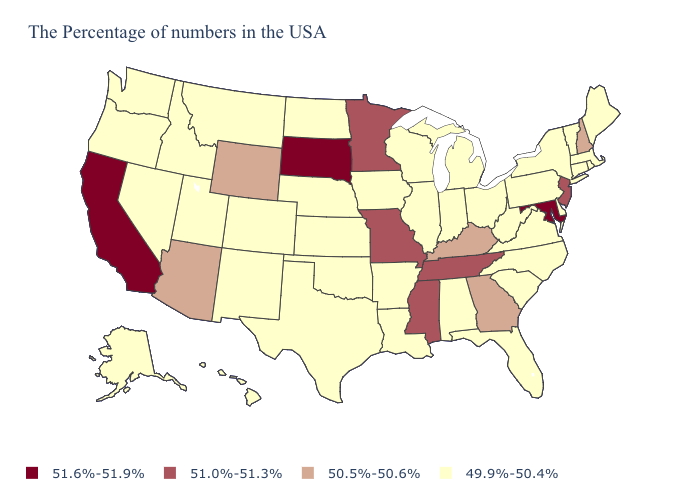Among the states that border Mississippi , does Tennessee have the lowest value?
Short answer required. No. Does Wyoming have the lowest value in the West?
Give a very brief answer. No. What is the value of West Virginia?
Concise answer only. 49.9%-50.4%. Does New Hampshire have the highest value in the USA?
Concise answer only. No. What is the value of Louisiana?
Be succinct. 49.9%-50.4%. What is the lowest value in the USA?
Short answer required. 49.9%-50.4%. Among the states that border North Carolina , which have the lowest value?
Concise answer only. Virginia, South Carolina. How many symbols are there in the legend?
Answer briefly. 4. Which states have the lowest value in the USA?
Concise answer only. Maine, Massachusetts, Rhode Island, Vermont, Connecticut, New York, Delaware, Pennsylvania, Virginia, North Carolina, South Carolina, West Virginia, Ohio, Florida, Michigan, Indiana, Alabama, Wisconsin, Illinois, Louisiana, Arkansas, Iowa, Kansas, Nebraska, Oklahoma, Texas, North Dakota, Colorado, New Mexico, Utah, Montana, Idaho, Nevada, Washington, Oregon, Alaska, Hawaii. Does Michigan have the lowest value in the MidWest?
Concise answer only. Yes. Among the states that border Mississippi , which have the highest value?
Write a very short answer. Tennessee. What is the value of Washington?
Quick response, please. 49.9%-50.4%. What is the value of Kentucky?
Be succinct. 50.5%-50.6%. What is the value of Iowa?
Keep it brief. 49.9%-50.4%. What is the value of Oklahoma?
Concise answer only. 49.9%-50.4%. 